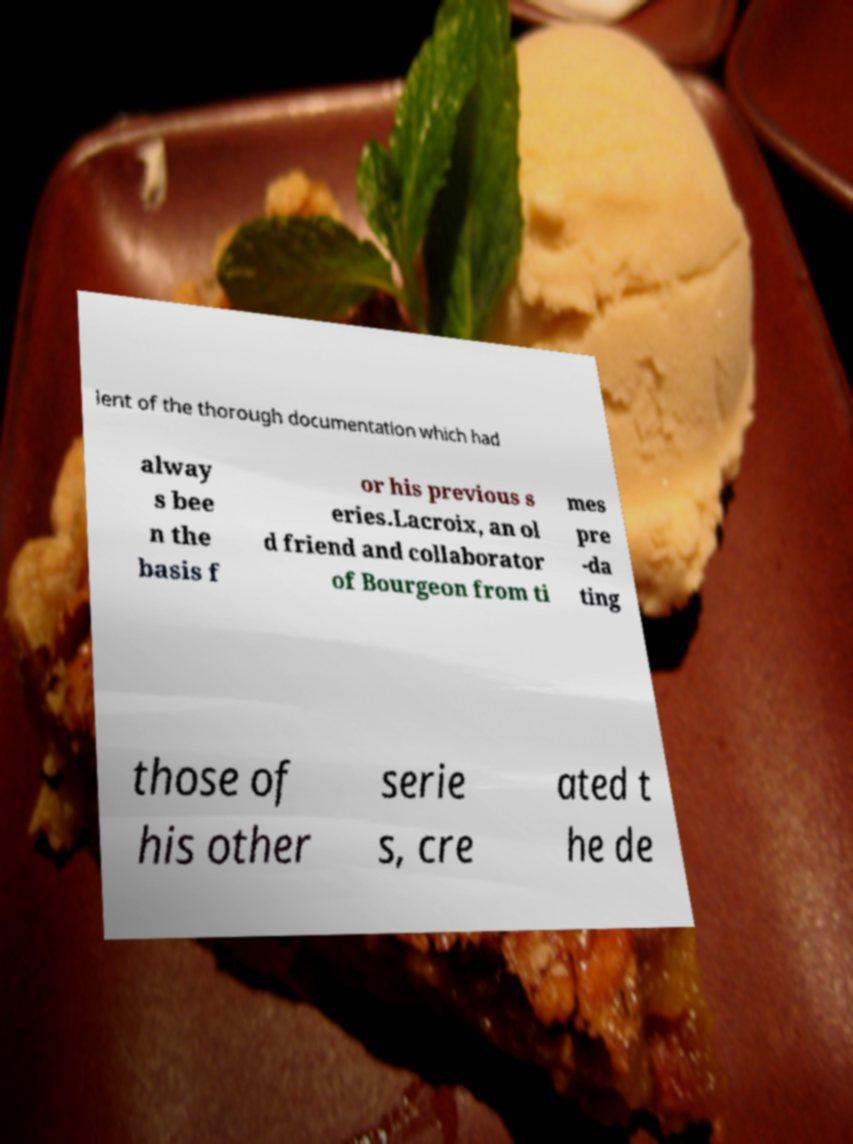Could you extract and type out the text from this image? lent of the thorough documentation which had alway s bee n the basis f or his previous s eries.Lacroix, an ol d friend and collaborator of Bourgeon from ti mes pre -da ting those of his other serie s, cre ated t he de 